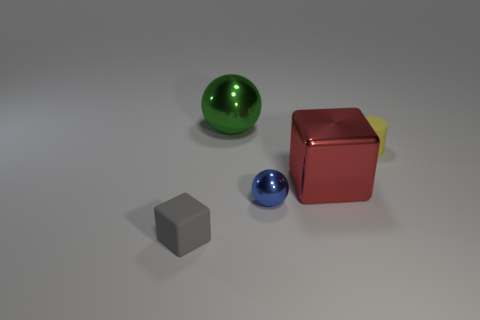Add 4 yellow matte cylinders. How many objects exist? 9 Subtract all blocks. How many objects are left? 3 Subtract all blocks. Subtract all yellow objects. How many objects are left? 2 Add 3 matte blocks. How many matte blocks are left? 4 Add 1 rubber cylinders. How many rubber cylinders exist? 2 Subtract 1 yellow cylinders. How many objects are left? 4 